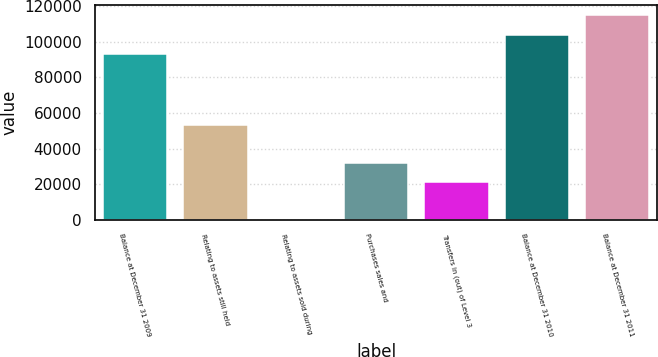Convert chart to OTSL. <chart><loc_0><loc_0><loc_500><loc_500><bar_chart><fcel>Balance at December 31 2009<fcel>Relating to assets still held<fcel>Relating to assets sold during<fcel>Purchases sales and<fcel>Transfers in (out) of Level 3<fcel>Balance at December 31 2010<fcel>Balance at December 31 2011<nl><fcel>93262<fcel>53400.7<fcel>0.37<fcel>32040.5<fcel>21360.5<fcel>103942<fcel>114622<nl></chart> 